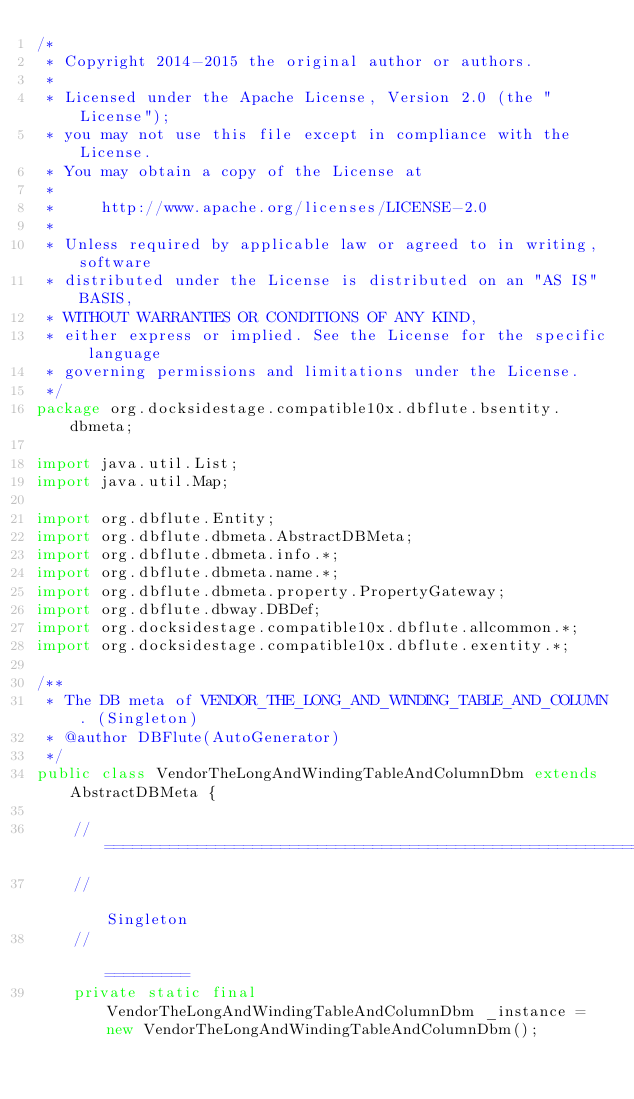<code> <loc_0><loc_0><loc_500><loc_500><_Java_>/*
 * Copyright 2014-2015 the original author or authors.
 *
 * Licensed under the Apache License, Version 2.0 (the "License");
 * you may not use this file except in compliance with the License.
 * You may obtain a copy of the License at
 *
 *     http://www.apache.org/licenses/LICENSE-2.0
 *
 * Unless required by applicable law or agreed to in writing, software
 * distributed under the License is distributed on an "AS IS" BASIS,
 * WITHOUT WARRANTIES OR CONDITIONS OF ANY KIND,
 * either express or implied. See the License for the specific language
 * governing permissions and limitations under the License.
 */
package org.docksidestage.compatible10x.dbflute.bsentity.dbmeta;

import java.util.List;
import java.util.Map;

import org.dbflute.Entity;
import org.dbflute.dbmeta.AbstractDBMeta;
import org.dbflute.dbmeta.info.*;
import org.dbflute.dbmeta.name.*;
import org.dbflute.dbmeta.property.PropertyGateway;
import org.dbflute.dbway.DBDef;
import org.docksidestage.compatible10x.dbflute.allcommon.*;
import org.docksidestage.compatible10x.dbflute.exentity.*;

/**
 * The DB meta of VENDOR_THE_LONG_AND_WINDING_TABLE_AND_COLUMN. (Singleton)
 * @author DBFlute(AutoGenerator)
 */
public class VendorTheLongAndWindingTableAndColumnDbm extends AbstractDBMeta {

    // ===================================================================================
    //                                                                           Singleton
    //                                                                           =========
    private static final VendorTheLongAndWindingTableAndColumnDbm _instance = new VendorTheLongAndWindingTableAndColumnDbm();</code> 